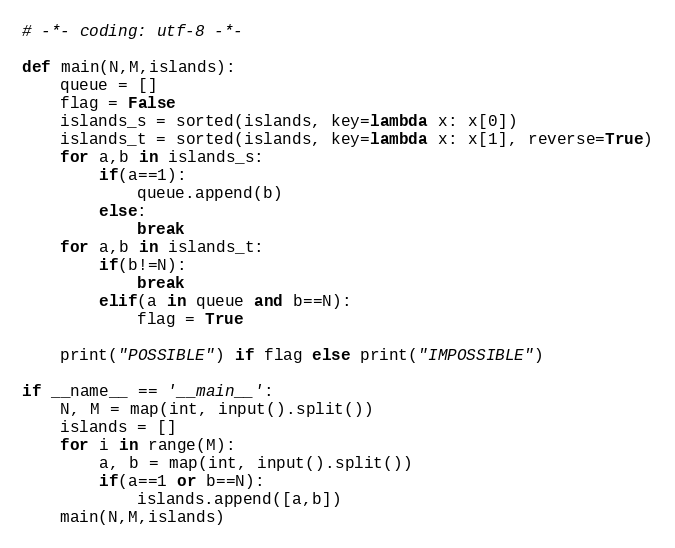<code> <loc_0><loc_0><loc_500><loc_500><_Python_># -*- coding: utf-8 -*-

def main(N,M,islands):
    queue = []
    flag = False
    islands_s = sorted(islands, key=lambda x: x[0])
    islands_t = sorted(islands, key=lambda x: x[1], reverse=True)
    for a,b in islands_s:
        if(a==1):
            queue.append(b)
        else:
            break
    for a,b in islands_t:
        if(b!=N):
            break
        elif(a in queue and b==N):
            flag = True
            
    print("POSSIBLE") if flag else print("IMPOSSIBLE")

if __name__ == '__main__':
    N, M = map(int, input().split())
    islands = []
    for i in range(M):
        a, b = map(int, input().split())
        if(a==1 or b==N):
            islands.append([a,b])
    main(N,M,islands)</code> 